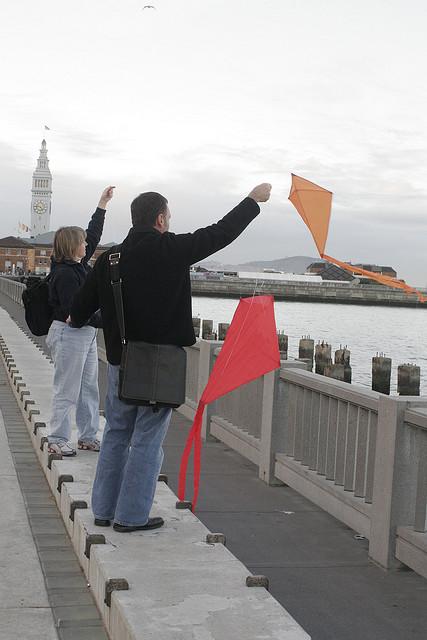Are they on a bridge?
Concise answer only. Yes. Is it sunny?
Write a very short answer. No. What activity are these people engaged in?
Answer briefly. Kite flying. What is the man holding?
Write a very short answer. Kite. 